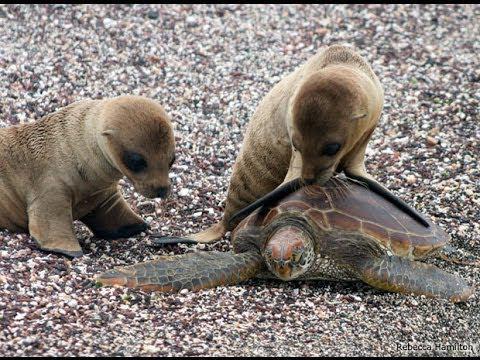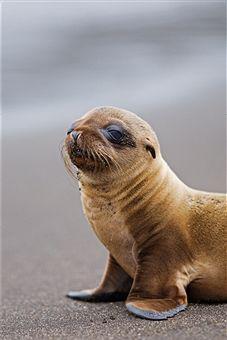The first image is the image on the left, the second image is the image on the right. Given the left and right images, does the statement "In one image there is a lone seal pup looking towards the left of the image." hold true? Answer yes or no. Yes. 